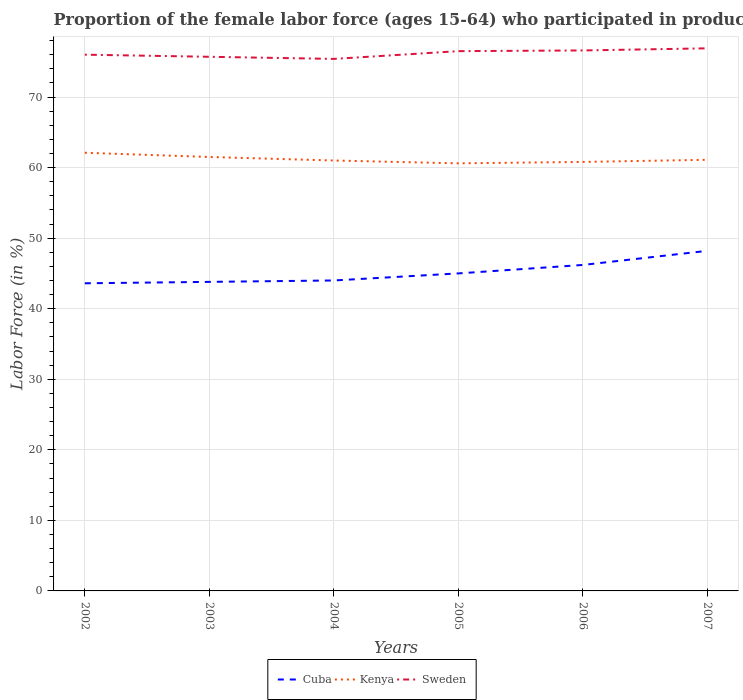How many different coloured lines are there?
Offer a very short reply. 3. Is the number of lines equal to the number of legend labels?
Keep it short and to the point. Yes. Across all years, what is the maximum proportion of the female labor force who participated in production in Kenya?
Provide a short and direct response. 60.6. What is the total proportion of the female labor force who participated in production in Kenya in the graph?
Ensure brevity in your answer.  1.1. What is the difference between the highest and the second highest proportion of the female labor force who participated in production in Cuba?
Your answer should be compact. 4.6. What is the difference between the highest and the lowest proportion of the female labor force who participated in production in Cuba?
Give a very brief answer. 2. How many lines are there?
Offer a very short reply. 3. What is the difference between two consecutive major ticks on the Y-axis?
Your response must be concise. 10. Are the values on the major ticks of Y-axis written in scientific E-notation?
Offer a terse response. No. Does the graph contain grids?
Your answer should be very brief. Yes. What is the title of the graph?
Offer a very short reply. Proportion of the female labor force (ages 15-64) who participated in production. Does "Sudan" appear as one of the legend labels in the graph?
Give a very brief answer. No. What is the label or title of the Y-axis?
Keep it short and to the point. Labor Force (in %). What is the Labor Force (in %) of Cuba in 2002?
Give a very brief answer. 43.6. What is the Labor Force (in %) in Kenya in 2002?
Your response must be concise. 62.1. What is the Labor Force (in %) in Sweden in 2002?
Offer a very short reply. 76. What is the Labor Force (in %) in Cuba in 2003?
Make the answer very short. 43.8. What is the Labor Force (in %) in Kenya in 2003?
Keep it short and to the point. 61.5. What is the Labor Force (in %) of Sweden in 2003?
Your answer should be compact. 75.7. What is the Labor Force (in %) of Kenya in 2004?
Provide a short and direct response. 61. What is the Labor Force (in %) of Sweden in 2004?
Your answer should be very brief. 75.4. What is the Labor Force (in %) in Kenya in 2005?
Provide a succinct answer. 60.6. What is the Labor Force (in %) of Sweden in 2005?
Your response must be concise. 76.5. What is the Labor Force (in %) of Cuba in 2006?
Make the answer very short. 46.2. What is the Labor Force (in %) of Kenya in 2006?
Offer a very short reply. 60.8. What is the Labor Force (in %) of Sweden in 2006?
Give a very brief answer. 76.6. What is the Labor Force (in %) in Cuba in 2007?
Your response must be concise. 48.2. What is the Labor Force (in %) in Kenya in 2007?
Provide a succinct answer. 61.1. What is the Labor Force (in %) in Sweden in 2007?
Your answer should be very brief. 76.9. Across all years, what is the maximum Labor Force (in %) of Cuba?
Provide a succinct answer. 48.2. Across all years, what is the maximum Labor Force (in %) of Kenya?
Ensure brevity in your answer.  62.1. Across all years, what is the maximum Labor Force (in %) in Sweden?
Provide a succinct answer. 76.9. Across all years, what is the minimum Labor Force (in %) of Cuba?
Ensure brevity in your answer.  43.6. Across all years, what is the minimum Labor Force (in %) in Kenya?
Offer a terse response. 60.6. Across all years, what is the minimum Labor Force (in %) of Sweden?
Your answer should be compact. 75.4. What is the total Labor Force (in %) of Cuba in the graph?
Provide a short and direct response. 270.8. What is the total Labor Force (in %) in Kenya in the graph?
Ensure brevity in your answer.  367.1. What is the total Labor Force (in %) in Sweden in the graph?
Give a very brief answer. 457.1. What is the difference between the Labor Force (in %) in Kenya in 2002 and that in 2003?
Your answer should be compact. 0.6. What is the difference between the Labor Force (in %) in Sweden in 2002 and that in 2003?
Your answer should be very brief. 0.3. What is the difference between the Labor Force (in %) in Cuba in 2002 and that in 2005?
Provide a short and direct response. -1.4. What is the difference between the Labor Force (in %) of Sweden in 2002 and that in 2005?
Offer a very short reply. -0.5. What is the difference between the Labor Force (in %) of Kenya in 2002 and that in 2006?
Your answer should be compact. 1.3. What is the difference between the Labor Force (in %) in Sweden in 2002 and that in 2007?
Give a very brief answer. -0.9. What is the difference between the Labor Force (in %) in Cuba in 2003 and that in 2004?
Give a very brief answer. -0.2. What is the difference between the Labor Force (in %) in Kenya in 2003 and that in 2004?
Make the answer very short. 0.5. What is the difference between the Labor Force (in %) of Kenya in 2003 and that in 2005?
Make the answer very short. 0.9. What is the difference between the Labor Force (in %) in Sweden in 2003 and that in 2005?
Give a very brief answer. -0.8. What is the difference between the Labor Force (in %) of Cuba in 2003 and that in 2006?
Your answer should be very brief. -2.4. What is the difference between the Labor Force (in %) in Kenya in 2003 and that in 2006?
Your response must be concise. 0.7. What is the difference between the Labor Force (in %) of Cuba in 2003 and that in 2007?
Ensure brevity in your answer.  -4.4. What is the difference between the Labor Force (in %) of Sweden in 2003 and that in 2007?
Make the answer very short. -1.2. What is the difference between the Labor Force (in %) in Cuba in 2004 and that in 2005?
Your answer should be compact. -1. What is the difference between the Labor Force (in %) in Kenya in 2004 and that in 2005?
Your answer should be very brief. 0.4. What is the difference between the Labor Force (in %) in Sweden in 2004 and that in 2005?
Your answer should be compact. -1.1. What is the difference between the Labor Force (in %) of Sweden in 2004 and that in 2006?
Give a very brief answer. -1.2. What is the difference between the Labor Force (in %) in Sweden in 2004 and that in 2007?
Ensure brevity in your answer.  -1.5. What is the difference between the Labor Force (in %) in Kenya in 2005 and that in 2006?
Provide a succinct answer. -0.2. What is the difference between the Labor Force (in %) of Cuba in 2005 and that in 2007?
Offer a terse response. -3.2. What is the difference between the Labor Force (in %) of Cuba in 2006 and that in 2007?
Offer a terse response. -2. What is the difference between the Labor Force (in %) of Cuba in 2002 and the Labor Force (in %) of Kenya in 2003?
Offer a terse response. -17.9. What is the difference between the Labor Force (in %) of Cuba in 2002 and the Labor Force (in %) of Sweden in 2003?
Keep it short and to the point. -32.1. What is the difference between the Labor Force (in %) in Cuba in 2002 and the Labor Force (in %) in Kenya in 2004?
Provide a succinct answer. -17.4. What is the difference between the Labor Force (in %) in Cuba in 2002 and the Labor Force (in %) in Sweden in 2004?
Offer a terse response. -31.8. What is the difference between the Labor Force (in %) of Cuba in 2002 and the Labor Force (in %) of Sweden in 2005?
Provide a short and direct response. -32.9. What is the difference between the Labor Force (in %) of Kenya in 2002 and the Labor Force (in %) of Sweden in 2005?
Offer a very short reply. -14.4. What is the difference between the Labor Force (in %) in Cuba in 2002 and the Labor Force (in %) in Kenya in 2006?
Your response must be concise. -17.2. What is the difference between the Labor Force (in %) in Cuba in 2002 and the Labor Force (in %) in Sweden in 2006?
Your answer should be very brief. -33. What is the difference between the Labor Force (in %) in Cuba in 2002 and the Labor Force (in %) in Kenya in 2007?
Make the answer very short. -17.5. What is the difference between the Labor Force (in %) in Cuba in 2002 and the Labor Force (in %) in Sweden in 2007?
Provide a short and direct response. -33.3. What is the difference between the Labor Force (in %) in Kenya in 2002 and the Labor Force (in %) in Sweden in 2007?
Give a very brief answer. -14.8. What is the difference between the Labor Force (in %) in Cuba in 2003 and the Labor Force (in %) in Kenya in 2004?
Ensure brevity in your answer.  -17.2. What is the difference between the Labor Force (in %) in Cuba in 2003 and the Labor Force (in %) in Sweden in 2004?
Provide a short and direct response. -31.6. What is the difference between the Labor Force (in %) of Cuba in 2003 and the Labor Force (in %) of Kenya in 2005?
Give a very brief answer. -16.8. What is the difference between the Labor Force (in %) of Cuba in 2003 and the Labor Force (in %) of Sweden in 2005?
Your answer should be very brief. -32.7. What is the difference between the Labor Force (in %) in Cuba in 2003 and the Labor Force (in %) in Sweden in 2006?
Offer a very short reply. -32.8. What is the difference between the Labor Force (in %) of Kenya in 2003 and the Labor Force (in %) of Sweden in 2006?
Offer a very short reply. -15.1. What is the difference between the Labor Force (in %) of Cuba in 2003 and the Labor Force (in %) of Kenya in 2007?
Make the answer very short. -17.3. What is the difference between the Labor Force (in %) in Cuba in 2003 and the Labor Force (in %) in Sweden in 2007?
Provide a succinct answer. -33.1. What is the difference between the Labor Force (in %) in Kenya in 2003 and the Labor Force (in %) in Sweden in 2007?
Ensure brevity in your answer.  -15.4. What is the difference between the Labor Force (in %) of Cuba in 2004 and the Labor Force (in %) of Kenya in 2005?
Your answer should be very brief. -16.6. What is the difference between the Labor Force (in %) in Cuba in 2004 and the Labor Force (in %) in Sweden in 2005?
Provide a short and direct response. -32.5. What is the difference between the Labor Force (in %) of Kenya in 2004 and the Labor Force (in %) of Sweden in 2005?
Keep it short and to the point. -15.5. What is the difference between the Labor Force (in %) of Cuba in 2004 and the Labor Force (in %) of Kenya in 2006?
Your response must be concise. -16.8. What is the difference between the Labor Force (in %) in Cuba in 2004 and the Labor Force (in %) in Sweden in 2006?
Offer a terse response. -32.6. What is the difference between the Labor Force (in %) of Kenya in 2004 and the Labor Force (in %) of Sweden in 2006?
Offer a terse response. -15.6. What is the difference between the Labor Force (in %) of Cuba in 2004 and the Labor Force (in %) of Kenya in 2007?
Make the answer very short. -17.1. What is the difference between the Labor Force (in %) in Cuba in 2004 and the Labor Force (in %) in Sweden in 2007?
Your answer should be compact. -32.9. What is the difference between the Labor Force (in %) in Kenya in 2004 and the Labor Force (in %) in Sweden in 2007?
Provide a short and direct response. -15.9. What is the difference between the Labor Force (in %) in Cuba in 2005 and the Labor Force (in %) in Kenya in 2006?
Ensure brevity in your answer.  -15.8. What is the difference between the Labor Force (in %) in Cuba in 2005 and the Labor Force (in %) in Sweden in 2006?
Provide a succinct answer. -31.6. What is the difference between the Labor Force (in %) in Cuba in 2005 and the Labor Force (in %) in Kenya in 2007?
Make the answer very short. -16.1. What is the difference between the Labor Force (in %) of Cuba in 2005 and the Labor Force (in %) of Sweden in 2007?
Offer a very short reply. -31.9. What is the difference between the Labor Force (in %) in Kenya in 2005 and the Labor Force (in %) in Sweden in 2007?
Keep it short and to the point. -16.3. What is the difference between the Labor Force (in %) of Cuba in 2006 and the Labor Force (in %) of Kenya in 2007?
Offer a very short reply. -14.9. What is the difference between the Labor Force (in %) of Cuba in 2006 and the Labor Force (in %) of Sweden in 2007?
Provide a short and direct response. -30.7. What is the difference between the Labor Force (in %) of Kenya in 2006 and the Labor Force (in %) of Sweden in 2007?
Ensure brevity in your answer.  -16.1. What is the average Labor Force (in %) in Cuba per year?
Your response must be concise. 45.13. What is the average Labor Force (in %) in Kenya per year?
Make the answer very short. 61.18. What is the average Labor Force (in %) of Sweden per year?
Give a very brief answer. 76.18. In the year 2002, what is the difference between the Labor Force (in %) of Cuba and Labor Force (in %) of Kenya?
Offer a very short reply. -18.5. In the year 2002, what is the difference between the Labor Force (in %) in Cuba and Labor Force (in %) in Sweden?
Ensure brevity in your answer.  -32.4. In the year 2002, what is the difference between the Labor Force (in %) of Kenya and Labor Force (in %) of Sweden?
Give a very brief answer. -13.9. In the year 2003, what is the difference between the Labor Force (in %) of Cuba and Labor Force (in %) of Kenya?
Ensure brevity in your answer.  -17.7. In the year 2003, what is the difference between the Labor Force (in %) in Cuba and Labor Force (in %) in Sweden?
Give a very brief answer. -31.9. In the year 2004, what is the difference between the Labor Force (in %) in Cuba and Labor Force (in %) in Sweden?
Make the answer very short. -31.4. In the year 2004, what is the difference between the Labor Force (in %) of Kenya and Labor Force (in %) of Sweden?
Your response must be concise. -14.4. In the year 2005, what is the difference between the Labor Force (in %) in Cuba and Labor Force (in %) in Kenya?
Make the answer very short. -15.6. In the year 2005, what is the difference between the Labor Force (in %) in Cuba and Labor Force (in %) in Sweden?
Make the answer very short. -31.5. In the year 2005, what is the difference between the Labor Force (in %) in Kenya and Labor Force (in %) in Sweden?
Your response must be concise. -15.9. In the year 2006, what is the difference between the Labor Force (in %) of Cuba and Labor Force (in %) of Kenya?
Make the answer very short. -14.6. In the year 2006, what is the difference between the Labor Force (in %) in Cuba and Labor Force (in %) in Sweden?
Make the answer very short. -30.4. In the year 2006, what is the difference between the Labor Force (in %) of Kenya and Labor Force (in %) of Sweden?
Your answer should be very brief. -15.8. In the year 2007, what is the difference between the Labor Force (in %) in Cuba and Labor Force (in %) in Kenya?
Provide a short and direct response. -12.9. In the year 2007, what is the difference between the Labor Force (in %) of Cuba and Labor Force (in %) of Sweden?
Ensure brevity in your answer.  -28.7. In the year 2007, what is the difference between the Labor Force (in %) of Kenya and Labor Force (in %) of Sweden?
Your response must be concise. -15.8. What is the ratio of the Labor Force (in %) in Kenya in 2002 to that in 2003?
Give a very brief answer. 1.01. What is the ratio of the Labor Force (in %) of Sweden in 2002 to that in 2003?
Offer a very short reply. 1. What is the ratio of the Labor Force (in %) of Cuba in 2002 to that in 2004?
Ensure brevity in your answer.  0.99. What is the ratio of the Labor Force (in %) of Kenya in 2002 to that in 2004?
Offer a terse response. 1.02. What is the ratio of the Labor Force (in %) of Cuba in 2002 to that in 2005?
Keep it short and to the point. 0.97. What is the ratio of the Labor Force (in %) in Kenya in 2002 to that in 2005?
Keep it short and to the point. 1.02. What is the ratio of the Labor Force (in %) in Cuba in 2002 to that in 2006?
Keep it short and to the point. 0.94. What is the ratio of the Labor Force (in %) in Kenya in 2002 to that in 2006?
Make the answer very short. 1.02. What is the ratio of the Labor Force (in %) of Sweden in 2002 to that in 2006?
Provide a short and direct response. 0.99. What is the ratio of the Labor Force (in %) in Cuba in 2002 to that in 2007?
Your response must be concise. 0.9. What is the ratio of the Labor Force (in %) in Kenya in 2002 to that in 2007?
Your answer should be compact. 1.02. What is the ratio of the Labor Force (in %) of Sweden in 2002 to that in 2007?
Your response must be concise. 0.99. What is the ratio of the Labor Force (in %) in Cuba in 2003 to that in 2004?
Offer a terse response. 1. What is the ratio of the Labor Force (in %) of Kenya in 2003 to that in 2004?
Provide a succinct answer. 1.01. What is the ratio of the Labor Force (in %) of Sweden in 2003 to that in 2004?
Make the answer very short. 1. What is the ratio of the Labor Force (in %) in Cuba in 2003 to that in 2005?
Offer a very short reply. 0.97. What is the ratio of the Labor Force (in %) of Kenya in 2003 to that in 2005?
Your answer should be very brief. 1.01. What is the ratio of the Labor Force (in %) in Sweden in 2003 to that in 2005?
Your response must be concise. 0.99. What is the ratio of the Labor Force (in %) in Cuba in 2003 to that in 2006?
Keep it short and to the point. 0.95. What is the ratio of the Labor Force (in %) in Kenya in 2003 to that in 2006?
Give a very brief answer. 1.01. What is the ratio of the Labor Force (in %) in Sweden in 2003 to that in 2006?
Ensure brevity in your answer.  0.99. What is the ratio of the Labor Force (in %) of Cuba in 2003 to that in 2007?
Keep it short and to the point. 0.91. What is the ratio of the Labor Force (in %) of Sweden in 2003 to that in 2007?
Provide a short and direct response. 0.98. What is the ratio of the Labor Force (in %) in Cuba in 2004 to that in 2005?
Your answer should be very brief. 0.98. What is the ratio of the Labor Force (in %) of Kenya in 2004 to that in 2005?
Provide a succinct answer. 1.01. What is the ratio of the Labor Force (in %) in Sweden in 2004 to that in 2005?
Offer a terse response. 0.99. What is the ratio of the Labor Force (in %) in Cuba in 2004 to that in 2006?
Provide a succinct answer. 0.95. What is the ratio of the Labor Force (in %) of Kenya in 2004 to that in 2006?
Your response must be concise. 1. What is the ratio of the Labor Force (in %) of Sweden in 2004 to that in 2006?
Ensure brevity in your answer.  0.98. What is the ratio of the Labor Force (in %) in Cuba in 2004 to that in 2007?
Your answer should be compact. 0.91. What is the ratio of the Labor Force (in %) in Sweden in 2004 to that in 2007?
Give a very brief answer. 0.98. What is the ratio of the Labor Force (in %) in Kenya in 2005 to that in 2006?
Ensure brevity in your answer.  1. What is the ratio of the Labor Force (in %) of Cuba in 2005 to that in 2007?
Provide a succinct answer. 0.93. What is the ratio of the Labor Force (in %) in Cuba in 2006 to that in 2007?
Your answer should be compact. 0.96. What is the ratio of the Labor Force (in %) in Sweden in 2006 to that in 2007?
Your response must be concise. 1. What is the difference between the highest and the second highest Labor Force (in %) in Kenya?
Your response must be concise. 0.6. What is the difference between the highest and the second highest Labor Force (in %) of Sweden?
Make the answer very short. 0.3. 